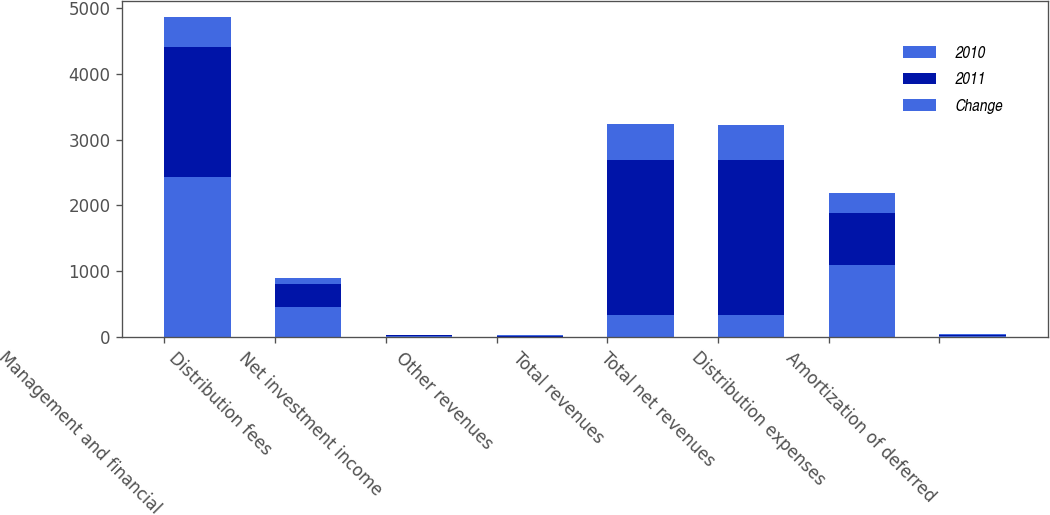Convert chart to OTSL. <chart><loc_0><loc_0><loc_500><loc_500><stacked_bar_chart><ecel><fcel>Management and financial<fcel>Distribution fees<fcel>Net investment income<fcel>Other revenues<fcel>Total revenues<fcel>Total net revenues<fcel>Distribution expenses<fcel>Amortization of deferred<nl><fcel>2010<fcel>2434<fcel>450<fcel>11<fcel>5<fcel>329.5<fcel>329.5<fcel>1095<fcel>19<nl><fcel>2011<fcel>1979<fcel>358<fcel>14<fcel>15<fcel>2366<fcel>2365<fcel>794<fcel>20<nl><fcel>Change<fcel>455<fcel>92<fcel>3<fcel>10<fcel>534<fcel>532<fcel>301<fcel>1<nl></chart> 